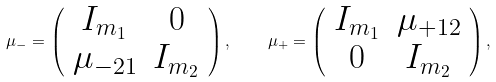<formula> <loc_0><loc_0><loc_500><loc_500>\mu _ { - } = \left ( \begin{array} { c c } { { I _ { m _ { 1 } } } } & { 0 } \\ { { \mu _ { - 2 1 } } } & { { I _ { m _ { 2 } } } } \end{array} \right ) , \quad \mu _ { + } = \left ( \begin{array} { c c } { { I _ { m _ { 1 } } } } & { { \mu _ { + 1 2 } } } \\ { 0 } & { { I _ { m _ { 2 } } } } \end{array} \right ) ,</formula> 